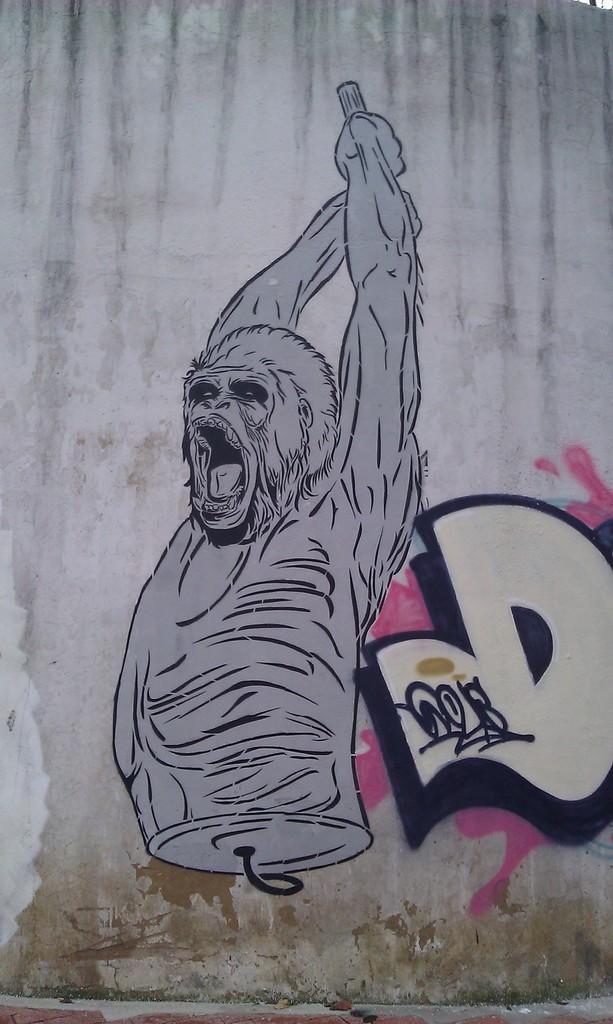In one or two sentences, can you explain what this image depicts? On the wall we can see the painting of an animal and there is a text and a sign on it. 